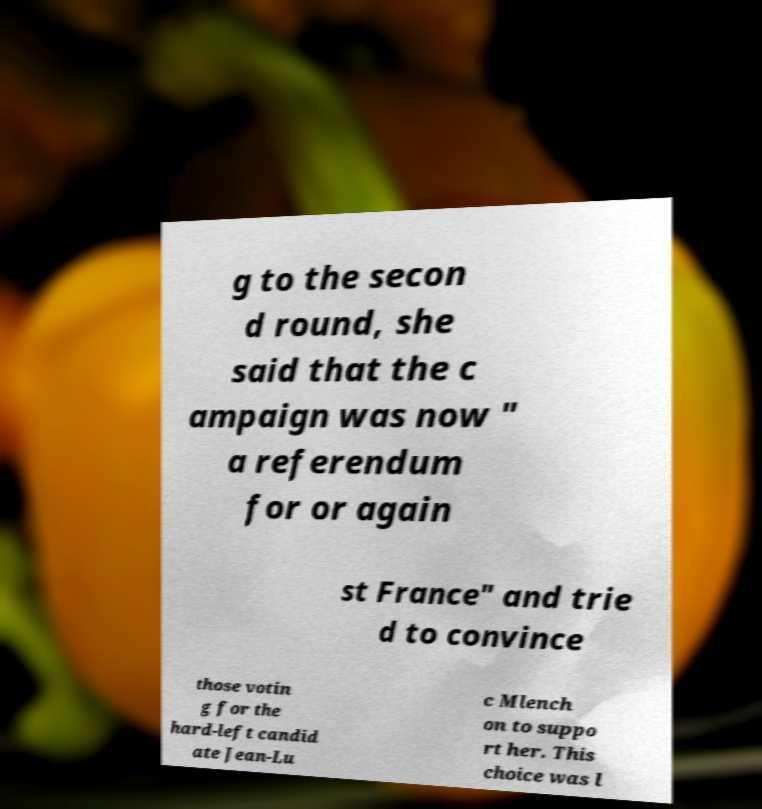I need the written content from this picture converted into text. Can you do that? g to the secon d round, she said that the c ampaign was now " a referendum for or again st France" and trie d to convince those votin g for the hard-left candid ate Jean-Lu c Mlench on to suppo rt her. This choice was l 